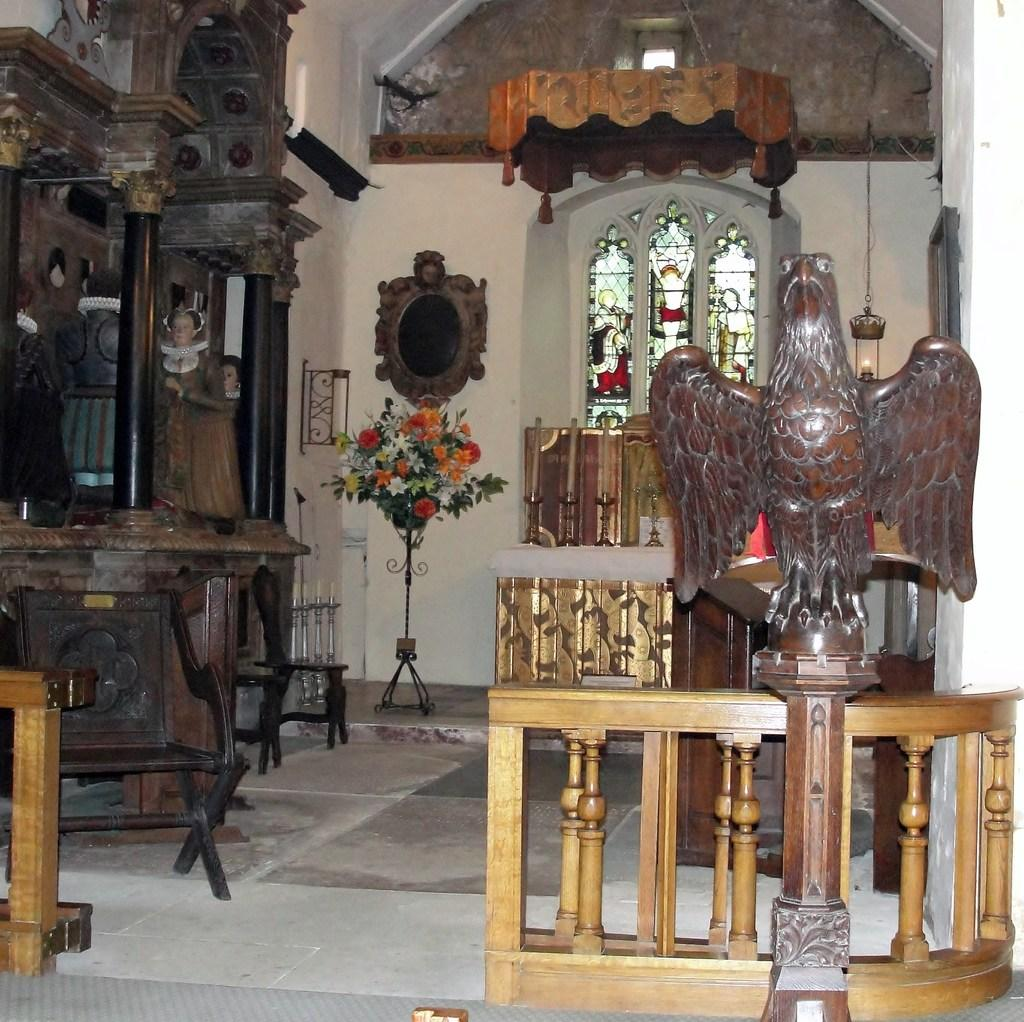What type of animal is depicted in the carving on the right side of the image? There is a carving of an eagle on the right side of the image. Are there any other wooden carvings in the image besides the eagle? Yes, there are other wooden carvings in the image. What type of pencil is being used to draw the horn on the wooden carving? There is no pencil or drawing activity present in the image; it features wooden carvings, including an eagle. What type of fowl is depicted in the wooden carvings? The provided facts do not mention any other specific animals besides the eagle. 